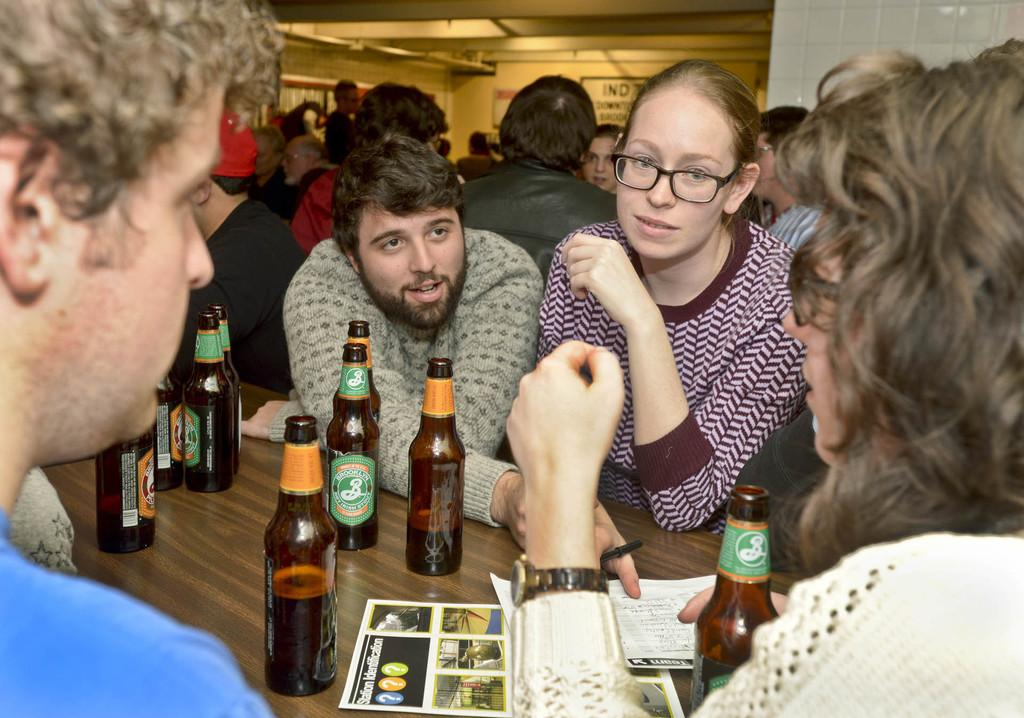How many people are in the image? There are several people in the image. What are the people doing in the image? The people are standing on either side of a table. What is on the table in the image? There are beer bottles on the table. What type of establishment might the setting be? The setting appears to be a bar. What type of beam is supporting the ceiling in the image? There is no beam visible in the image, as the focus is on the people and the table. What arithmetic problem can be solved using the number of people in the image? There is no arithmetic problem mentioned or implied in the image, as it is focused on the people and their surroundings. 